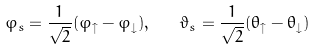<formula> <loc_0><loc_0><loc_500><loc_500>\varphi _ { s } = { \frac { 1 } { \sqrt { 2 } } } ( \varphi _ { \uparrow } - \varphi _ { \downarrow } ) , \quad \vartheta _ { s } = { \frac { 1 } { \sqrt { 2 } } } ( \theta _ { \uparrow } - \theta _ { \downarrow } )</formula> 